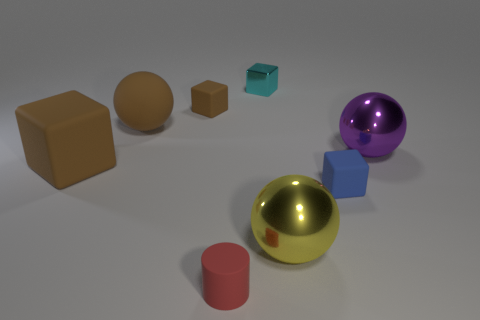What size is the matte ball that is the same color as the big matte block?
Your answer should be very brief. Large. What is the color of the large matte cube?
Keep it short and to the point. Brown. There is a large ball that is on the left side of the tiny red thing; what material is it?
Provide a succinct answer. Rubber. There is a cyan shiny object that is the same shape as the small blue rubber object; what is its size?
Offer a very short reply. Small. Are there fewer tiny cyan metallic cubes in front of the large brown matte block than metallic things?
Your answer should be very brief. Yes. Is there a big yellow thing?
Offer a terse response. Yes. The large rubber thing that is the same shape as the tiny cyan metallic thing is what color?
Make the answer very short. Brown. Does the object that is in front of the large yellow metal object have the same color as the tiny metal block?
Your response must be concise. No. Does the brown rubber sphere have the same size as the purple shiny object?
Give a very brief answer. Yes. There is a tiny red object that is the same material as the blue cube; what is its shape?
Ensure brevity in your answer.  Cylinder. 